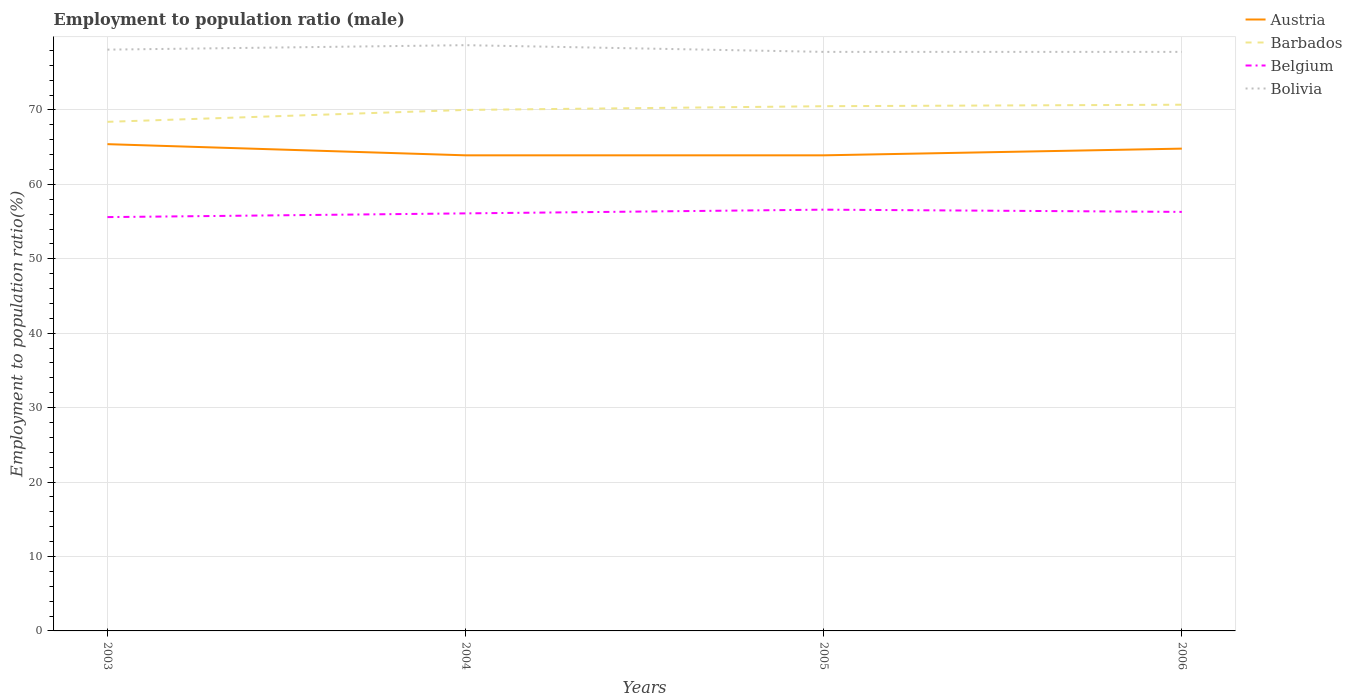Does the line corresponding to Belgium intersect with the line corresponding to Bolivia?
Offer a very short reply. No. Is the number of lines equal to the number of legend labels?
Make the answer very short. Yes. Across all years, what is the maximum employment to population ratio in Austria?
Provide a succinct answer. 63.9. What is the total employment to population ratio in Bolivia in the graph?
Provide a succinct answer. 0.9. What is the difference between the highest and the second highest employment to population ratio in Barbados?
Your answer should be very brief. 2.3. How many lines are there?
Offer a terse response. 4. What is the difference between two consecutive major ticks on the Y-axis?
Your answer should be very brief. 10. Does the graph contain any zero values?
Provide a succinct answer. No. Does the graph contain grids?
Keep it short and to the point. Yes. How many legend labels are there?
Your response must be concise. 4. What is the title of the graph?
Ensure brevity in your answer.  Employment to population ratio (male). Does "Central Europe" appear as one of the legend labels in the graph?
Your answer should be very brief. No. What is the label or title of the X-axis?
Ensure brevity in your answer.  Years. What is the Employment to population ratio(%) of Austria in 2003?
Your answer should be very brief. 65.4. What is the Employment to population ratio(%) in Barbados in 2003?
Give a very brief answer. 68.4. What is the Employment to population ratio(%) in Belgium in 2003?
Offer a terse response. 55.6. What is the Employment to population ratio(%) of Bolivia in 2003?
Your answer should be compact. 78.1. What is the Employment to population ratio(%) in Austria in 2004?
Offer a terse response. 63.9. What is the Employment to population ratio(%) in Barbados in 2004?
Offer a very short reply. 70. What is the Employment to population ratio(%) of Belgium in 2004?
Your answer should be very brief. 56.1. What is the Employment to population ratio(%) of Bolivia in 2004?
Your answer should be compact. 78.7. What is the Employment to population ratio(%) in Austria in 2005?
Make the answer very short. 63.9. What is the Employment to population ratio(%) in Barbados in 2005?
Keep it short and to the point. 70.5. What is the Employment to population ratio(%) in Belgium in 2005?
Give a very brief answer. 56.6. What is the Employment to population ratio(%) in Bolivia in 2005?
Ensure brevity in your answer.  77.8. What is the Employment to population ratio(%) in Austria in 2006?
Offer a very short reply. 64.8. What is the Employment to population ratio(%) of Barbados in 2006?
Offer a very short reply. 70.7. What is the Employment to population ratio(%) of Belgium in 2006?
Give a very brief answer. 56.3. What is the Employment to population ratio(%) in Bolivia in 2006?
Offer a terse response. 77.8. Across all years, what is the maximum Employment to population ratio(%) in Austria?
Make the answer very short. 65.4. Across all years, what is the maximum Employment to population ratio(%) of Barbados?
Give a very brief answer. 70.7. Across all years, what is the maximum Employment to population ratio(%) in Belgium?
Give a very brief answer. 56.6. Across all years, what is the maximum Employment to population ratio(%) in Bolivia?
Keep it short and to the point. 78.7. Across all years, what is the minimum Employment to population ratio(%) in Austria?
Offer a very short reply. 63.9. Across all years, what is the minimum Employment to population ratio(%) in Barbados?
Provide a short and direct response. 68.4. Across all years, what is the minimum Employment to population ratio(%) in Belgium?
Provide a succinct answer. 55.6. Across all years, what is the minimum Employment to population ratio(%) of Bolivia?
Your answer should be compact. 77.8. What is the total Employment to population ratio(%) of Austria in the graph?
Provide a short and direct response. 258. What is the total Employment to population ratio(%) of Barbados in the graph?
Ensure brevity in your answer.  279.6. What is the total Employment to population ratio(%) of Belgium in the graph?
Give a very brief answer. 224.6. What is the total Employment to population ratio(%) of Bolivia in the graph?
Your answer should be very brief. 312.4. What is the difference between the Employment to population ratio(%) in Austria in 2003 and that in 2004?
Your answer should be compact. 1.5. What is the difference between the Employment to population ratio(%) of Bolivia in 2003 and that in 2004?
Keep it short and to the point. -0.6. What is the difference between the Employment to population ratio(%) of Barbados in 2003 and that in 2005?
Your answer should be very brief. -2.1. What is the difference between the Employment to population ratio(%) of Bolivia in 2003 and that in 2005?
Make the answer very short. 0.3. What is the difference between the Employment to population ratio(%) of Austria in 2003 and that in 2006?
Your answer should be very brief. 0.6. What is the difference between the Employment to population ratio(%) of Barbados in 2003 and that in 2006?
Provide a short and direct response. -2.3. What is the difference between the Employment to population ratio(%) of Belgium in 2003 and that in 2006?
Keep it short and to the point. -0.7. What is the difference between the Employment to population ratio(%) in Bolivia in 2003 and that in 2006?
Your answer should be very brief. 0.3. What is the difference between the Employment to population ratio(%) of Austria in 2004 and that in 2005?
Keep it short and to the point. 0. What is the difference between the Employment to population ratio(%) of Bolivia in 2004 and that in 2005?
Provide a short and direct response. 0.9. What is the difference between the Employment to population ratio(%) in Austria in 2004 and that in 2006?
Offer a terse response. -0.9. What is the difference between the Employment to population ratio(%) in Barbados in 2004 and that in 2006?
Provide a short and direct response. -0.7. What is the difference between the Employment to population ratio(%) of Austria in 2005 and that in 2006?
Make the answer very short. -0.9. What is the difference between the Employment to population ratio(%) of Barbados in 2005 and that in 2006?
Provide a short and direct response. -0.2. What is the difference between the Employment to population ratio(%) in Austria in 2003 and the Employment to population ratio(%) in Barbados in 2004?
Provide a short and direct response. -4.6. What is the difference between the Employment to population ratio(%) of Austria in 2003 and the Employment to population ratio(%) of Belgium in 2004?
Your answer should be very brief. 9.3. What is the difference between the Employment to population ratio(%) in Barbados in 2003 and the Employment to population ratio(%) in Belgium in 2004?
Your answer should be very brief. 12.3. What is the difference between the Employment to population ratio(%) of Barbados in 2003 and the Employment to population ratio(%) of Bolivia in 2004?
Offer a very short reply. -10.3. What is the difference between the Employment to population ratio(%) in Belgium in 2003 and the Employment to population ratio(%) in Bolivia in 2004?
Ensure brevity in your answer.  -23.1. What is the difference between the Employment to population ratio(%) of Austria in 2003 and the Employment to population ratio(%) of Barbados in 2005?
Ensure brevity in your answer.  -5.1. What is the difference between the Employment to population ratio(%) in Barbados in 2003 and the Employment to population ratio(%) in Bolivia in 2005?
Your answer should be very brief. -9.4. What is the difference between the Employment to population ratio(%) in Belgium in 2003 and the Employment to population ratio(%) in Bolivia in 2005?
Your answer should be compact. -22.2. What is the difference between the Employment to population ratio(%) in Austria in 2003 and the Employment to population ratio(%) in Bolivia in 2006?
Your answer should be compact. -12.4. What is the difference between the Employment to population ratio(%) in Barbados in 2003 and the Employment to population ratio(%) in Belgium in 2006?
Provide a short and direct response. 12.1. What is the difference between the Employment to population ratio(%) of Barbados in 2003 and the Employment to population ratio(%) of Bolivia in 2006?
Make the answer very short. -9.4. What is the difference between the Employment to population ratio(%) in Belgium in 2003 and the Employment to population ratio(%) in Bolivia in 2006?
Offer a terse response. -22.2. What is the difference between the Employment to population ratio(%) in Austria in 2004 and the Employment to population ratio(%) in Barbados in 2005?
Give a very brief answer. -6.6. What is the difference between the Employment to population ratio(%) in Austria in 2004 and the Employment to population ratio(%) in Belgium in 2005?
Provide a succinct answer. 7.3. What is the difference between the Employment to population ratio(%) of Austria in 2004 and the Employment to population ratio(%) of Bolivia in 2005?
Give a very brief answer. -13.9. What is the difference between the Employment to population ratio(%) in Barbados in 2004 and the Employment to population ratio(%) in Bolivia in 2005?
Keep it short and to the point. -7.8. What is the difference between the Employment to population ratio(%) of Belgium in 2004 and the Employment to population ratio(%) of Bolivia in 2005?
Provide a succinct answer. -21.7. What is the difference between the Employment to population ratio(%) of Belgium in 2004 and the Employment to population ratio(%) of Bolivia in 2006?
Give a very brief answer. -21.7. What is the difference between the Employment to population ratio(%) in Austria in 2005 and the Employment to population ratio(%) in Belgium in 2006?
Keep it short and to the point. 7.6. What is the difference between the Employment to population ratio(%) in Austria in 2005 and the Employment to population ratio(%) in Bolivia in 2006?
Make the answer very short. -13.9. What is the difference between the Employment to population ratio(%) of Barbados in 2005 and the Employment to population ratio(%) of Belgium in 2006?
Make the answer very short. 14.2. What is the difference between the Employment to population ratio(%) of Belgium in 2005 and the Employment to population ratio(%) of Bolivia in 2006?
Your response must be concise. -21.2. What is the average Employment to population ratio(%) in Austria per year?
Your answer should be compact. 64.5. What is the average Employment to population ratio(%) of Barbados per year?
Your answer should be compact. 69.9. What is the average Employment to population ratio(%) of Belgium per year?
Make the answer very short. 56.15. What is the average Employment to population ratio(%) in Bolivia per year?
Your response must be concise. 78.1. In the year 2003, what is the difference between the Employment to population ratio(%) in Austria and Employment to population ratio(%) in Barbados?
Your response must be concise. -3. In the year 2003, what is the difference between the Employment to population ratio(%) in Austria and Employment to population ratio(%) in Belgium?
Provide a succinct answer. 9.8. In the year 2003, what is the difference between the Employment to population ratio(%) in Barbados and Employment to population ratio(%) in Bolivia?
Offer a terse response. -9.7. In the year 2003, what is the difference between the Employment to population ratio(%) of Belgium and Employment to population ratio(%) of Bolivia?
Make the answer very short. -22.5. In the year 2004, what is the difference between the Employment to population ratio(%) of Austria and Employment to population ratio(%) of Bolivia?
Provide a short and direct response. -14.8. In the year 2004, what is the difference between the Employment to population ratio(%) in Barbados and Employment to population ratio(%) in Belgium?
Offer a terse response. 13.9. In the year 2004, what is the difference between the Employment to population ratio(%) in Belgium and Employment to population ratio(%) in Bolivia?
Offer a terse response. -22.6. In the year 2005, what is the difference between the Employment to population ratio(%) of Austria and Employment to population ratio(%) of Barbados?
Ensure brevity in your answer.  -6.6. In the year 2005, what is the difference between the Employment to population ratio(%) in Austria and Employment to population ratio(%) in Belgium?
Your answer should be compact. 7.3. In the year 2005, what is the difference between the Employment to population ratio(%) of Barbados and Employment to population ratio(%) of Belgium?
Give a very brief answer. 13.9. In the year 2005, what is the difference between the Employment to population ratio(%) of Belgium and Employment to population ratio(%) of Bolivia?
Offer a terse response. -21.2. In the year 2006, what is the difference between the Employment to population ratio(%) in Austria and Employment to population ratio(%) in Belgium?
Provide a short and direct response. 8.5. In the year 2006, what is the difference between the Employment to population ratio(%) of Barbados and Employment to population ratio(%) of Bolivia?
Give a very brief answer. -7.1. In the year 2006, what is the difference between the Employment to population ratio(%) in Belgium and Employment to population ratio(%) in Bolivia?
Offer a very short reply. -21.5. What is the ratio of the Employment to population ratio(%) of Austria in 2003 to that in 2004?
Give a very brief answer. 1.02. What is the ratio of the Employment to population ratio(%) of Barbados in 2003 to that in 2004?
Provide a short and direct response. 0.98. What is the ratio of the Employment to population ratio(%) of Belgium in 2003 to that in 2004?
Give a very brief answer. 0.99. What is the ratio of the Employment to population ratio(%) of Austria in 2003 to that in 2005?
Your answer should be very brief. 1.02. What is the ratio of the Employment to population ratio(%) in Barbados in 2003 to that in 2005?
Provide a short and direct response. 0.97. What is the ratio of the Employment to population ratio(%) of Belgium in 2003 to that in 2005?
Keep it short and to the point. 0.98. What is the ratio of the Employment to population ratio(%) in Austria in 2003 to that in 2006?
Ensure brevity in your answer.  1.01. What is the ratio of the Employment to population ratio(%) of Barbados in 2003 to that in 2006?
Keep it short and to the point. 0.97. What is the ratio of the Employment to population ratio(%) in Belgium in 2003 to that in 2006?
Keep it short and to the point. 0.99. What is the ratio of the Employment to population ratio(%) of Austria in 2004 to that in 2005?
Provide a short and direct response. 1. What is the ratio of the Employment to population ratio(%) in Barbados in 2004 to that in 2005?
Offer a terse response. 0.99. What is the ratio of the Employment to population ratio(%) in Belgium in 2004 to that in 2005?
Provide a succinct answer. 0.99. What is the ratio of the Employment to population ratio(%) of Bolivia in 2004 to that in 2005?
Your response must be concise. 1.01. What is the ratio of the Employment to population ratio(%) in Austria in 2004 to that in 2006?
Your response must be concise. 0.99. What is the ratio of the Employment to population ratio(%) of Belgium in 2004 to that in 2006?
Provide a succinct answer. 1. What is the ratio of the Employment to population ratio(%) in Bolivia in 2004 to that in 2006?
Keep it short and to the point. 1.01. What is the ratio of the Employment to population ratio(%) in Austria in 2005 to that in 2006?
Your answer should be very brief. 0.99. What is the ratio of the Employment to population ratio(%) in Barbados in 2005 to that in 2006?
Ensure brevity in your answer.  1. What is the ratio of the Employment to population ratio(%) in Belgium in 2005 to that in 2006?
Give a very brief answer. 1.01. What is the difference between the highest and the second highest Employment to population ratio(%) in Belgium?
Offer a very short reply. 0.3. What is the difference between the highest and the lowest Employment to population ratio(%) of Austria?
Offer a very short reply. 1.5. What is the difference between the highest and the lowest Employment to population ratio(%) in Barbados?
Make the answer very short. 2.3. What is the difference between the highest and the lowest Employment to population ratio(%) in Belgium?
Offer a terse response. 1. 